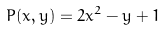<formula> <loc_0><loc_0><loc_500><loc_500>P ( x , y ) = 2 x ^ { 2 } - y + 1</formula> 